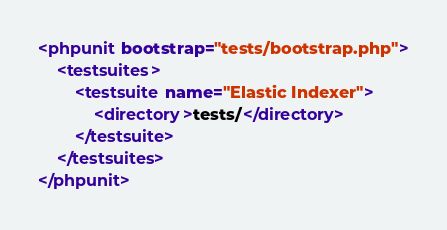<code> <loc_0><loc_0><loc_500><loc_500><_XML_><phpunit bootstrap="tests/bootstrap.php">
    <testsuites>
        <testsuite name="Elastic Indexer">
            <directory>tests/</directory>
        </testsuite>
    </testsuites>
</phpunit></code> 